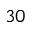<formula> <loc_0><loc_0><loc_500><loc_500>^ { 3 0 }</formula> 